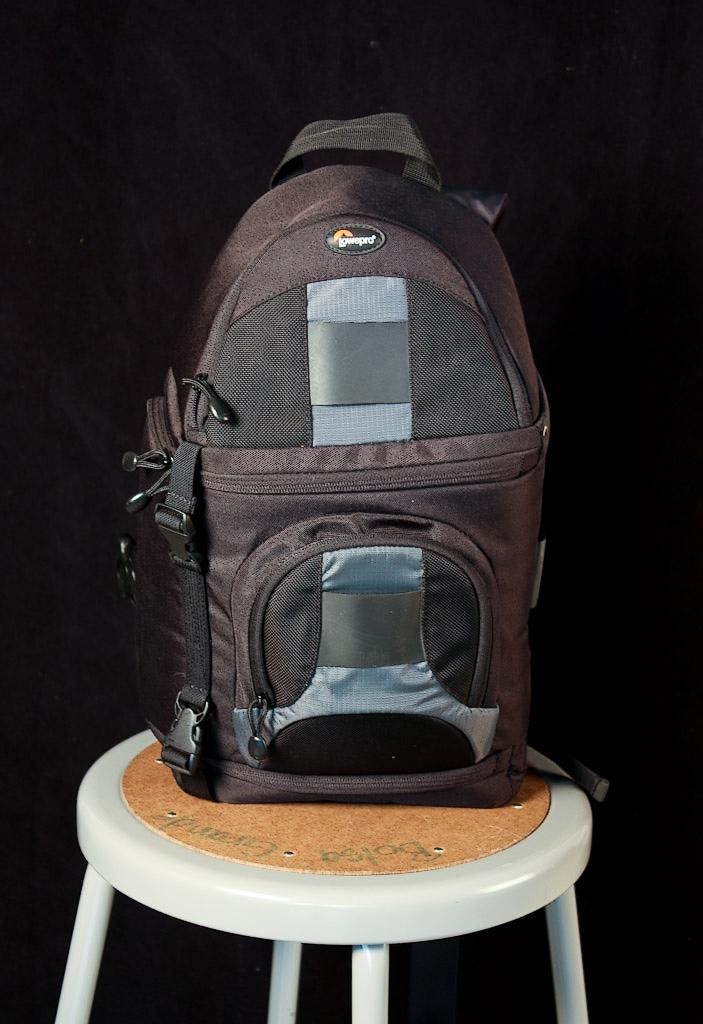What object is present in the image? There is a bag in the image. What can be seen on the bag? The bag has a brand name written on it. Where is the bag located in the image? The bag is on a stool. What is the income of the person reading a book near the bag in the image? There is no person reading a book near the bag in the image, and therefore no information about their income can be determined. 